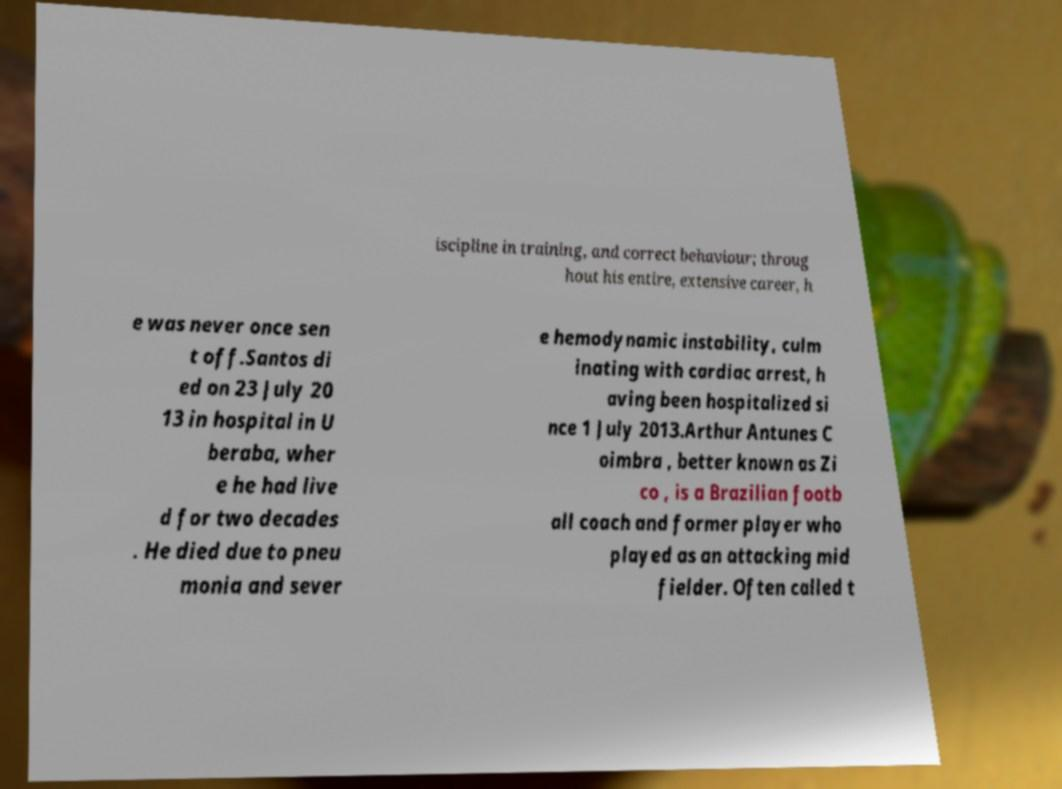For documentation purposes, I need the text within this image transcribed. Could you provide that? iscipline in training, and correct behaviour; throug hout his entire, extensive career, h e was never once sen t off.Santos di ed on 23 July 20 13 in hospital in U beraba, wher e he had live d for two decades . He died due to pneu monia and sever e hemodynamic instability, culm inating with cardiac arrest, h aving been hospitalized si nce 1 July 2013.Arthur Antunes C oimbra , better known as Zi co , is a Brazilian footb all coach and former player who played as an attacking mid fielder. Often called t 